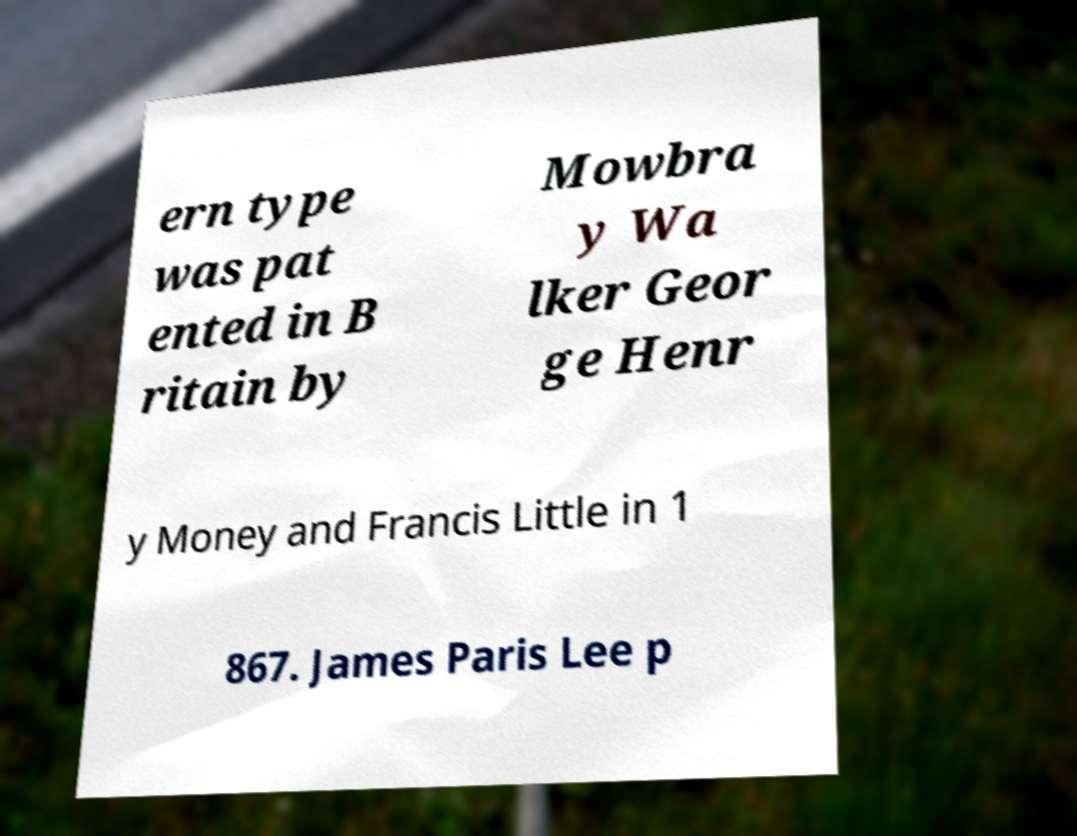Could you extract and type out the text from this image? ern type was pat ented in B ritain by Mowbra y Wa lker Geor ge Henr y Money and Francis Little in 1 867. James Paris Lee p 